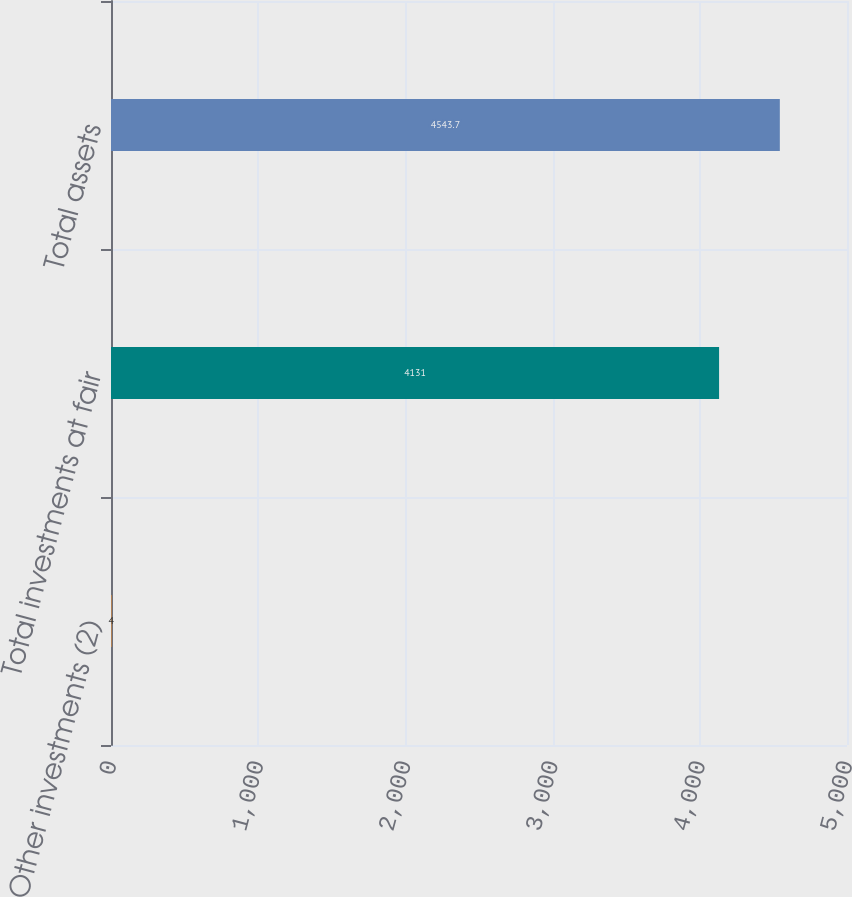Convert chart. <chart><loc_0><loc_0><loc_500><loc_500><bar_chart><fcel>Other investments (2)<fcel>Total investments at fair<fcel>Total assets<nl><fcel>4<fcel>4131<fcel>4543.7<nl></chart> 